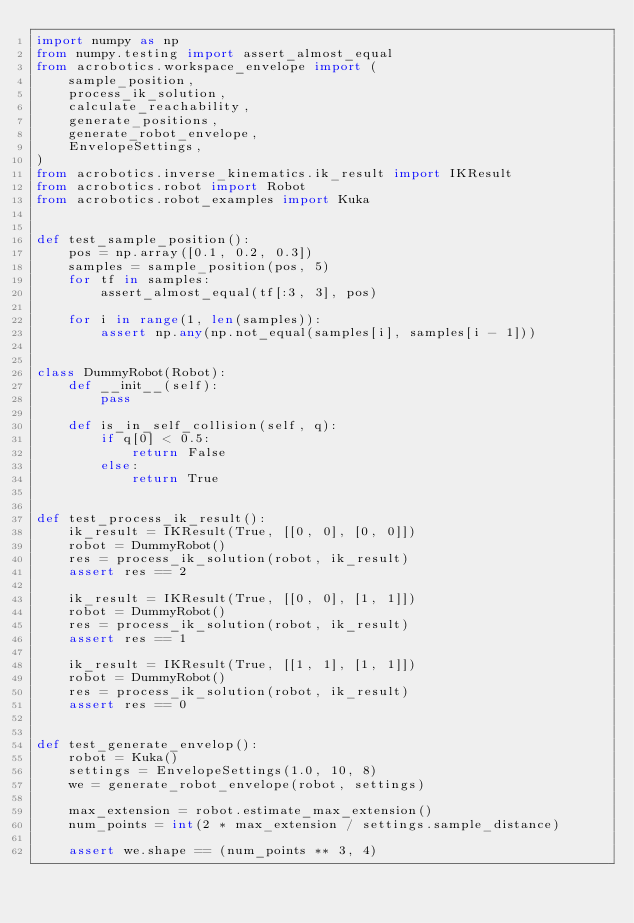<code> <loc_0><loc_0><loc_500><loc_500><_Python_>import numpy as np
from numpy.testing import assert_almost_equal
from acrobotics.workspace_envelope import (
    sample_position,
    process_ik_solution,
    calculate_reachability,
    generate_positions,
    generate_robot_envelope,
    EnvelopeSettings,
)
from acrobotics.inverse_kinematics.ik_result import IKResult
from acrobotics.robot import Robot
from acrobotics.robot_examples import Kuka


def test_sample_position():
    pos = np.array([0.1, 0.2, 0.3])
    samples = sample_position(pos, 5)
    for tf in samples:
        assert_almost_equal(tf[:3, 3], pos)

    for i in range(1, len(samples)):
        assert np.any(np.not_equal(samples[i], samples[i - 1]))


class DummyRobot(Robot):
    def __init__(self):
        pass

    def is_in_self_collision(self, q):
        if q[0] < 0.5:
            return False
        else:
            return True


def test_process_ik_result():
    ik_result = IKResult(True, [[0, 0], [0, 0]])
    robot = DummyRobot()
    res = process_ik_solution(robot, ik_result)
    assert res == 2

    ik_result = IKResult(True, [[0, 0], [1, 1]])
    robot = DummyRobot()
    res = process_ik_solution(robot, ik_result)
    assert res == 1

    ik_result = IKResult(True, [[1, 1], [1, 1]])
    robot = DummyRobot()
    res = process_ik_solution(robot, ik_result)
    assert res == 0


def test_generate_envelop():
    robot = Kuka()
    settings = EnvelopeSettings(1.0, 10, 8)
    we = generate_robot_envelope(robot, settings)

    max_extension = robot.estimate_max_extension()
    num_points = int(2 * max_extension / settings.sample_distance)

    assert we.shape == (num_points ** 3, 4)
</code> 